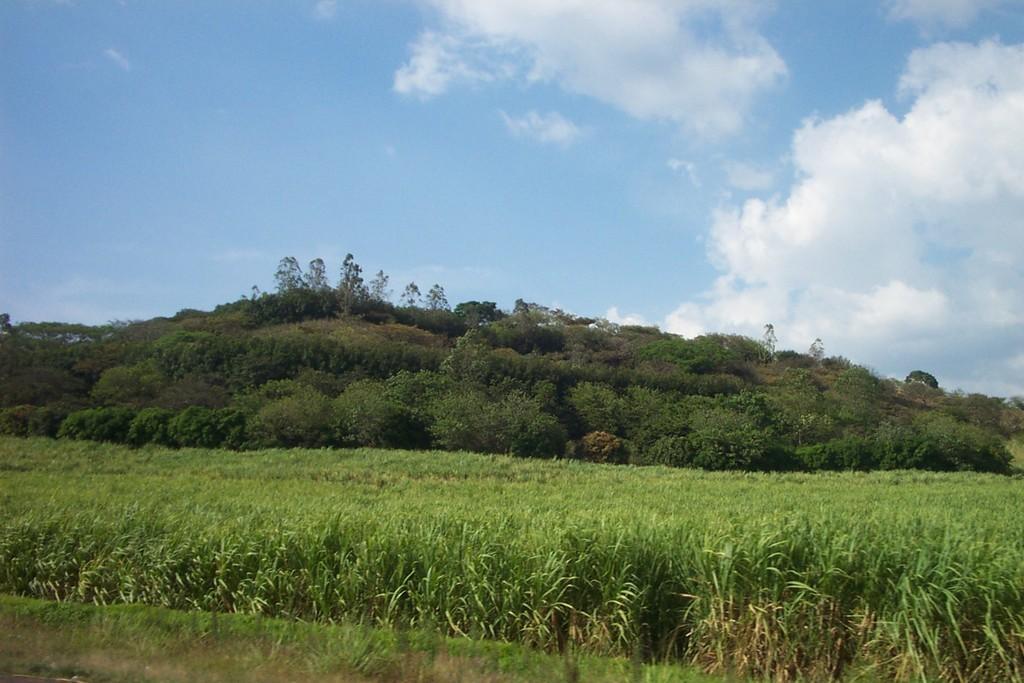Can you describe this image briefly? In this picture we can see plants, trees and clouds. 